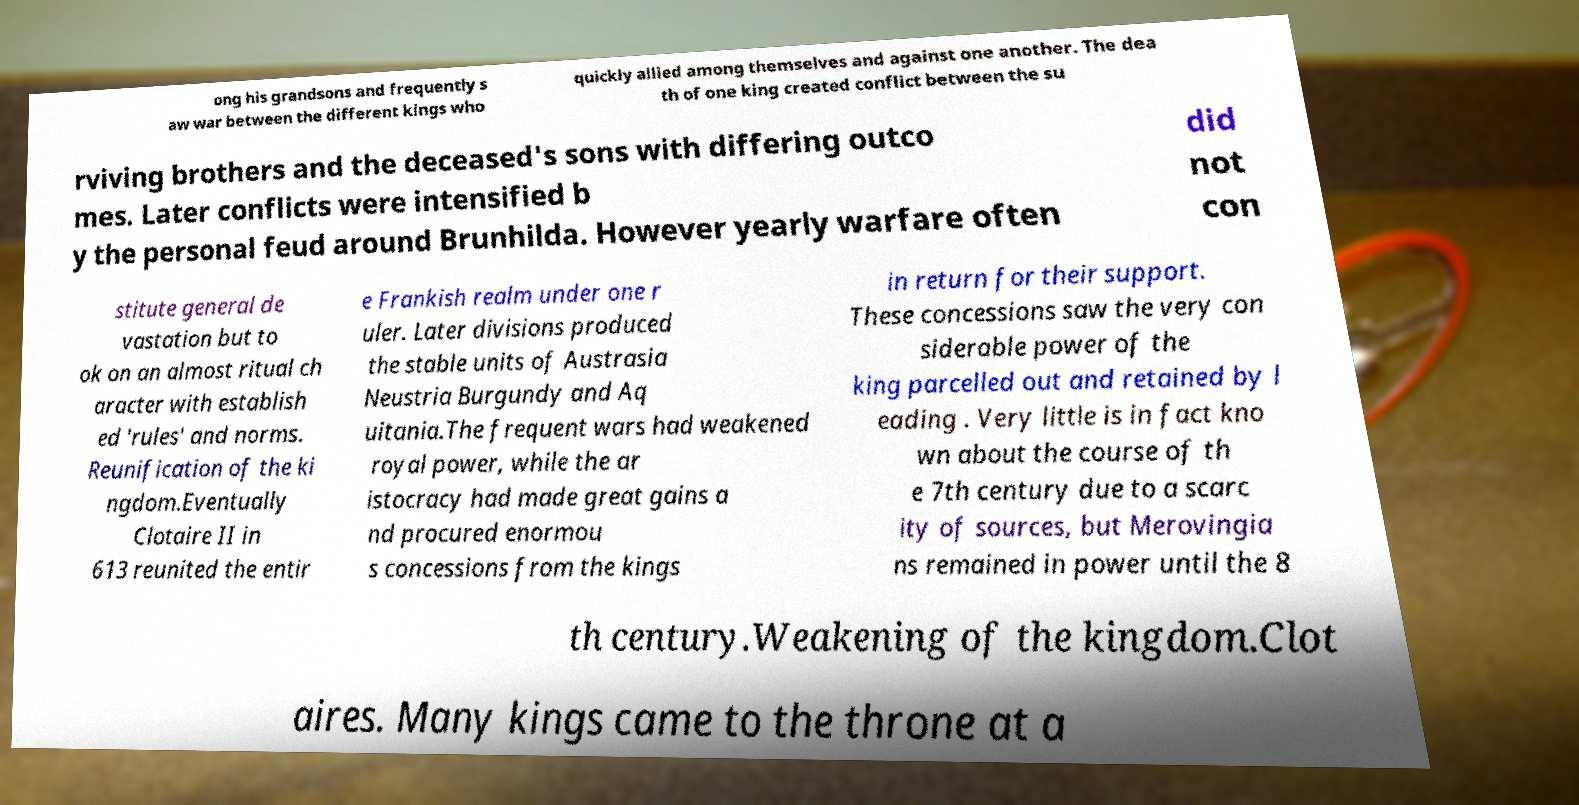Could you extract and type out the text from this image? ong his grandsons and frequently s aw war between the different kings who quickly allied among themselves and against one another. The dea th of one king created conflict between the su rviving brothers and the deceased's sons with differing outco mes. Later conflicts were intensified b y the personal feud around Brunhilda. However yearly warfare often did not con stitute general de vastation but to ok on an almost ritual ch aracter with establish ed 'rules' and norms. Reunification of the ki ngdom.Eventually Clotaire II in 613 reunited the entir e Frankish realm under one r uler. Later divisions produced the stable units of Austrasia Neustria Burgundy and Aq uitania.The frequent wars had weakened royal power, while the ar istocracy had made great gains a nd procured enormou s concessions from the kings in return for their support. These concessions saw the very con siderable power of the king parcelled out and retained by l eading . Very little is in fact kno wn about the course of th e 7th century due to a scarc ity of sources, but Merovingia ns remained in power until the 8 th century.Weakening of the kingdom.Clot aires. Many kings came to the throne at a 